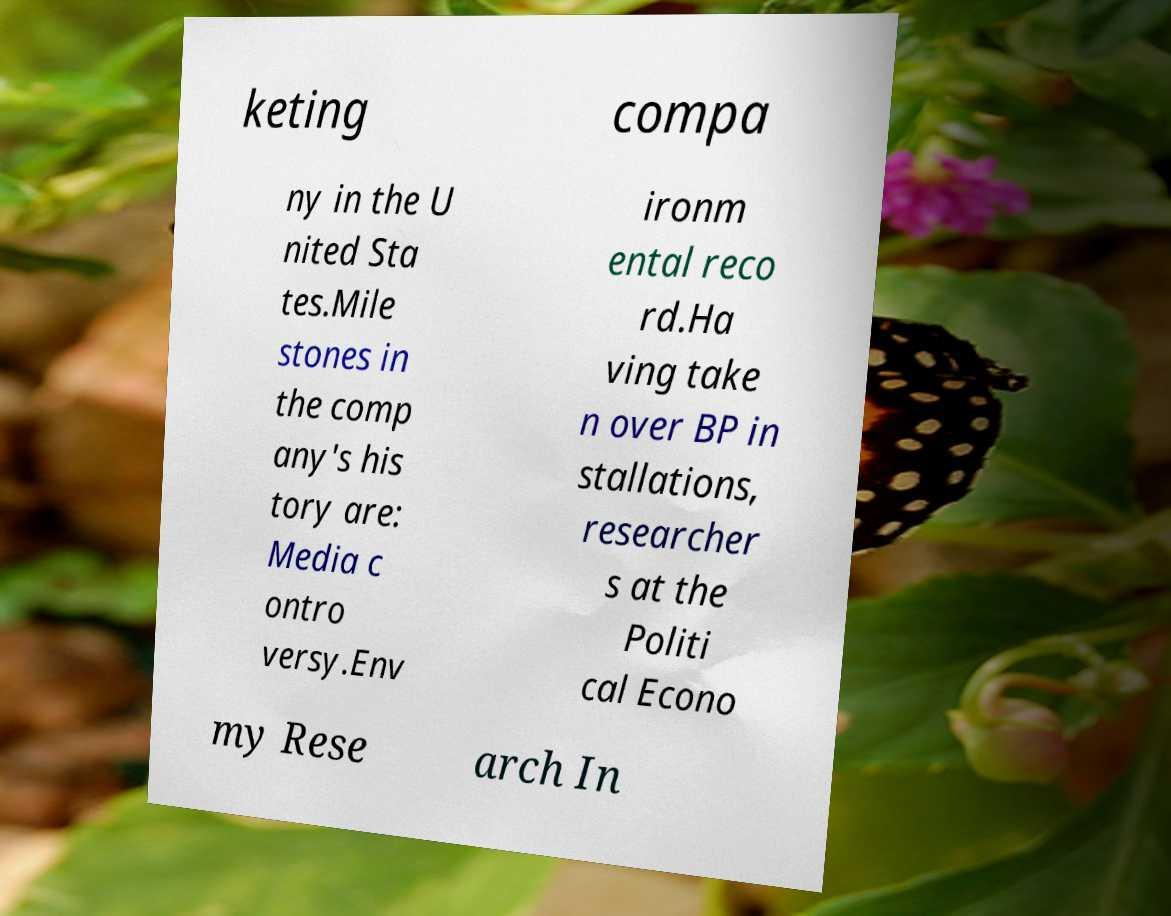What messages or text are displayed in this image? I need them in a readable, typed format. keting compa ny in the U nited Sta tes.Mile stones in the comp any's his tory are: Media c ontro versy.Env ironm ental reco rd.Ha ving take n over BP in stallations, researcher s at the Politi cal Econo my Rese arch In 